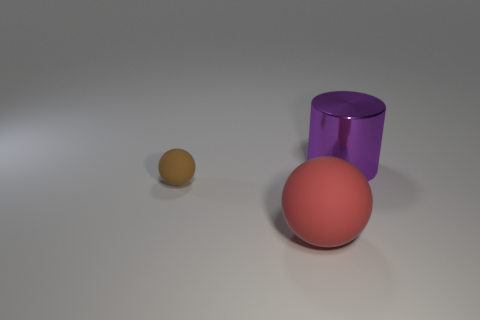What number of other objects are there of the same size as the shiny object?
Provide a short and direct response. 1. Is the number of large cylinders greater than the number of brown metallic balls?
Your answer should be very brief. Yes. What number of things are in front of the brown sphere and behind the brown sphere?
Ensure brevity in your answer.  0. There is a big thing that is to the left of the big thing that is right of the rubber sphere that is to the right of the tiny rubber ball; what shape is it?
Ensure brevity in your answer.  Sphere. Is there anything else that is the same shape as the tiny thing?
Offer a terse response. Yes. How many balls are either large purple metallic objects or big matte things?
Offer a terse response. 1. The ball to the right of the sphere that is behind the large thing in front of the purple shiny cylinder is made of what material?
Keep it short and to the point. Rubber. Does the brown thing have the same size as the purple thing?
Your answer should be compact. No. There is a brown object that is made of the same material as the red object; what shape is it?
Offer a very short reply. Sphere. There is a rubber thing that is right of the brown sphere; is its shape the same as the tiny brown rubber thing?
Offer a terse response. Yes. 